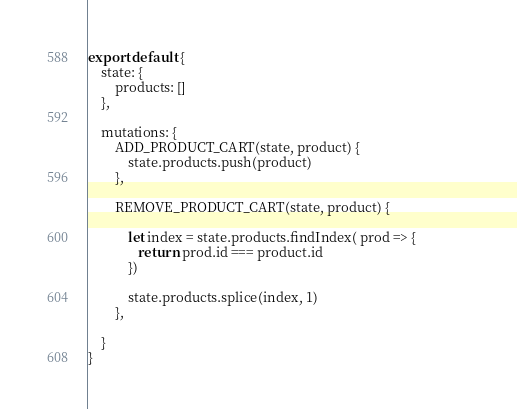Convert code to text. <code><loc_0><loc_0><loc_500><loc_500><_JavaScript_>export default {
    state: {
        products: []
    },

    mutations: {
        ADD_PRODUCT_CART(state, product) {
            state.products.push(product)
        },

        REMOVE_PRODUCT_CART(state, product) {

            let index = state.products.findIndex( prod => {                
               return prod.id === product.id
            }) 

            state.products.splice(index, 1)
        },
        
    }
}</code> 